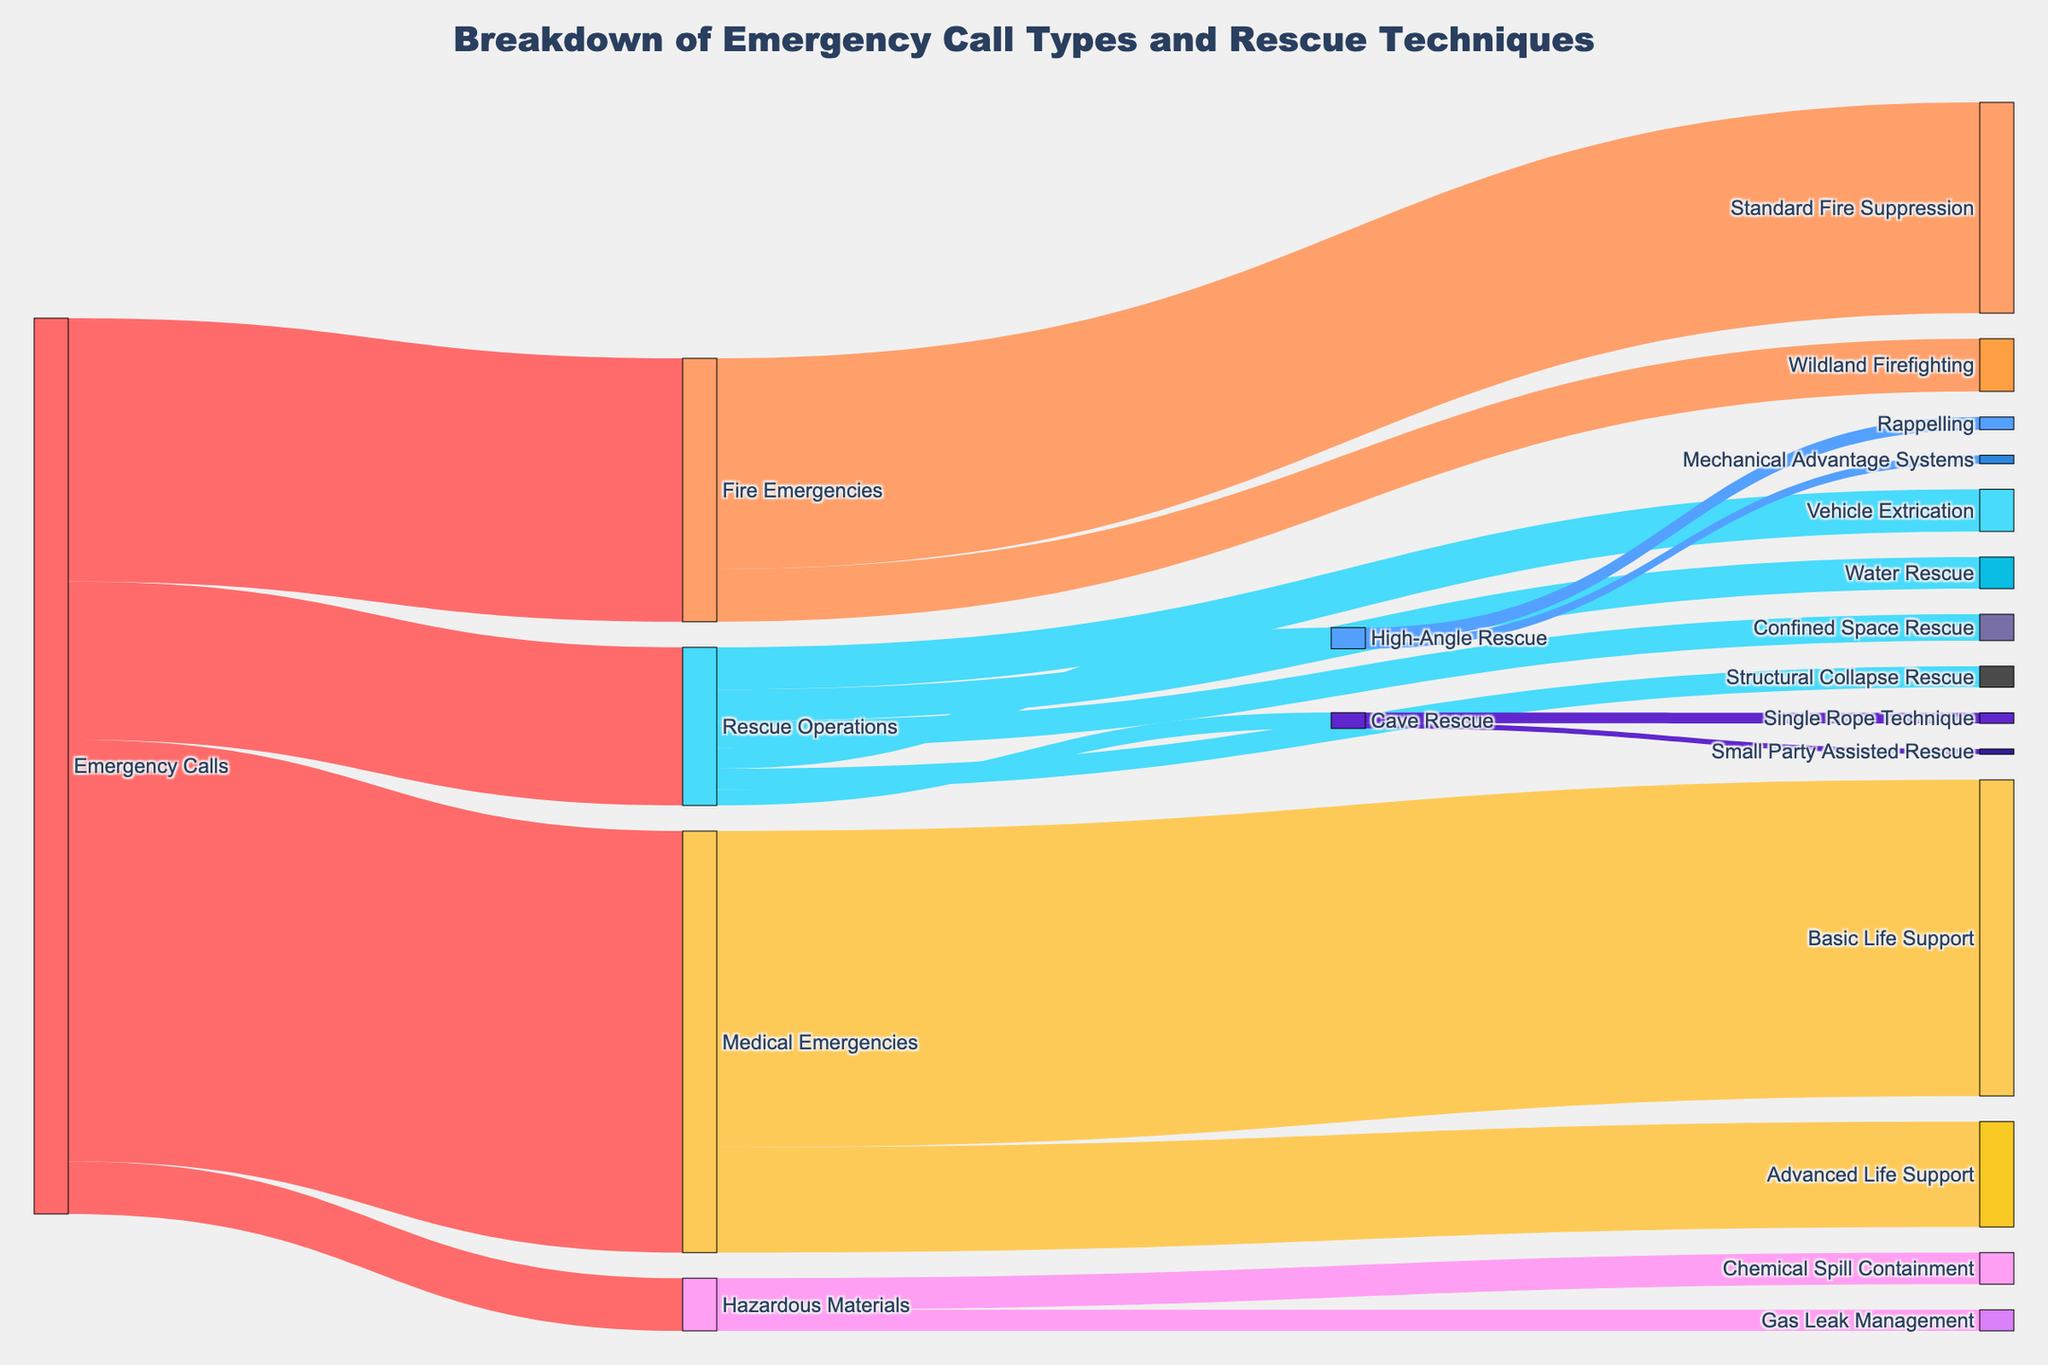What's the total number of emergency calls recorded? The figure shows the breakdown of all emergency calls into different types. To find the total, sum up the values for "Fire Emergencies," "Medical Emergencies," "Rescue Operations," and "Hazardous Materials" which are 250, 400, 150, and 50 respectively. So, the total is 250 + 400 + 150 + 50
Answer: 850 Which emergency call type had the highest number? By looking at the values directly linked to "Emergency Calls," we see that "Medical Emergencies" has the highest value of 400 compared to the others.
Answer: Medical Emergencies What is the most common rescue technique used under Fire Emergencies? Under "Fire Emergencies," the two techniques are "Standard Fire Suppression" with a value of 200 and "Wildland Firefighting" with a value of 50. The most common one is "Standard Fire Suppression."
Answer: Standard Fire Suppression Compare the frequency of Cave Rescue to Confined Space Rescue in Rescue Operations. Under "Rescue Operations," "Cave Rescue" has a value of 15, while "Confined Space Rescue" has a value of 25. Thus, "Confined Space Rescue" is more frequent.
Answer: Confined Space Rescue What's the combined total of all rescue techniques utilized under Rescue Operations? Sum the values for all rescue techniques under "Rescue Operations": Vehicle Extrication (40), Water Rescue (30), High-Angle Rescue (20), Cave Rescue (15), Confined Space Rescue (25), and Structural Collapse Rescue (20). Thus, the total is 40 + 30 + 20 + 15 + 25 + 20 = 150.
Answer: 150 Identify the frequency difference between Basic Life Support and Advanced Life Support. The values for "Basic Life Support" and "Advanced Life Support" under "Medical Emergencies" are 300 and 100 respectively. The difference is 300 - 100.
Answer: 200 What portion of the High-Angle Rescue techniques involve rappelling? Under "High-Angle Rescue," 12 out of 20 techniques involve "Rappelling". To find the portion, divide 12 by 20.
Answer: 60% How many rescue techniques under Cave Rescue involve Small Party Assisted Rescue? Under "Cave Rescue," "Small Party Assisted Rescue" has a value of 5.
Answer: 5 Compare the total instances of High-Angle Rescue techniques to Cave Rescue techniques. The total for "High-Angle Rescue" is 20, which includes "Rappelling" (12) and "Mechanical Advantage Systems" (8). The total for "Cave Rescue" is 15, which includes "Single Rope Technique" (10) and "Small Party Assisted Rescue" (5). Therefore, "High-Angle Rescue" has more instances.
Answer: High-Angle Rescue What is the primary technique used in Hazardous Materials emergencies? For "Hazardous Materials" emergencies, there are "Chemical Spill Containment" with a value of 30 and "Gas Leak Management" with a value of 20. The primary technique is "Chemical Spill Containment."
Answer: Chemical Spill Containment 